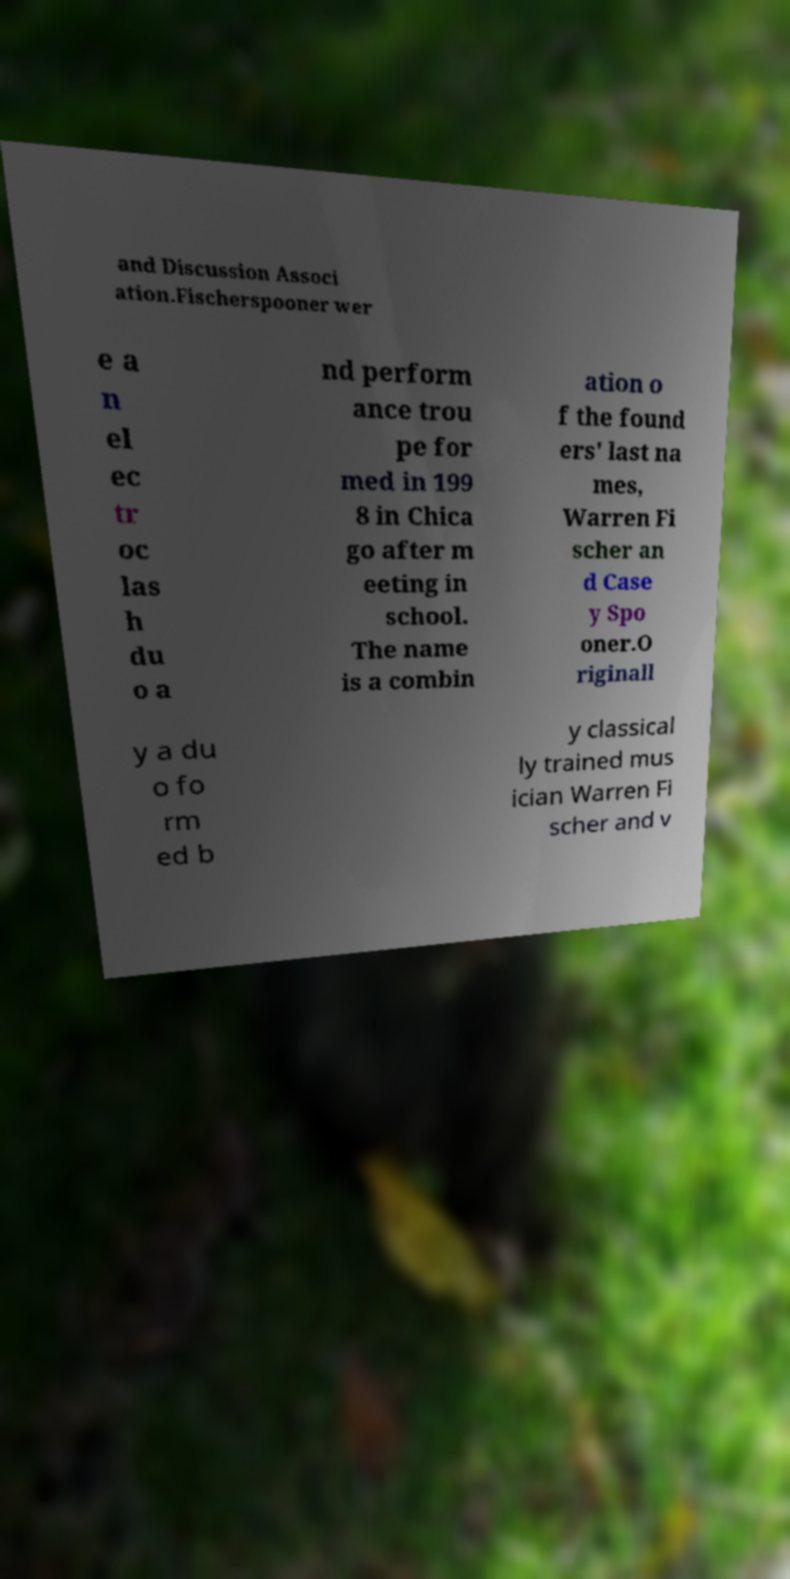Could you extract and type out the text from this image? and Discussion Associ ation.Fischerspooner wer e a n el ec tr oc las h du o a nd perform ance trou pe for med in 199 8 in Chica go after m eeting in school. The name is a combin ation o f the found ers' last na mes, Warren Fi scher an d Case y Spo oner.O riginall y a du o fo rm ed b y classical ly trained mus ician Warren Fi scher and v 